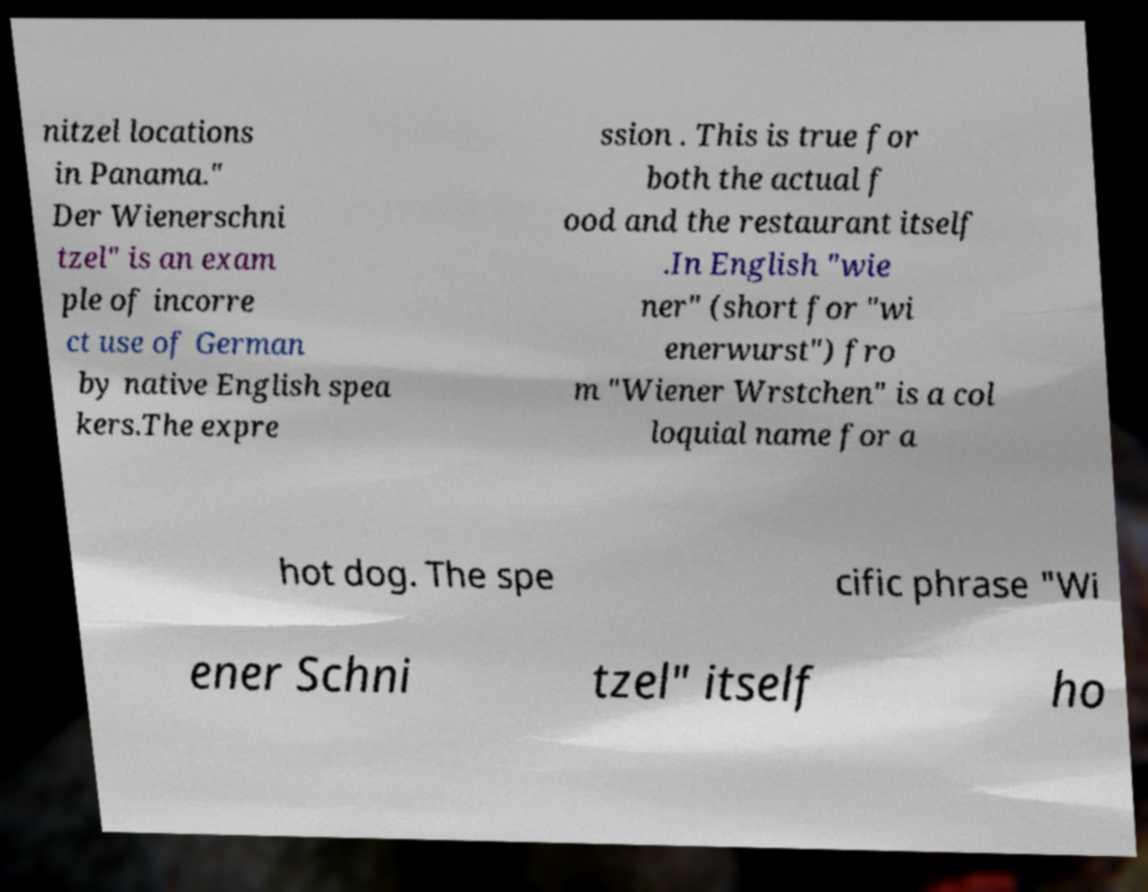Could you extract and type out the text from this image? nitzel locations in Panama." Der Wienerschni tzel" is an exam ple of incorre ct use of German by native English spea kers.The expre ssion . This is true for both the actual f ood and the restaurant itself .In English "wie ner" (short for "wi enerwurst") fro m "Wiener Wrstchen" is a col loquial name for a hot dog. The spe cific phrase "Wi ener Schni tzel" itself ho 